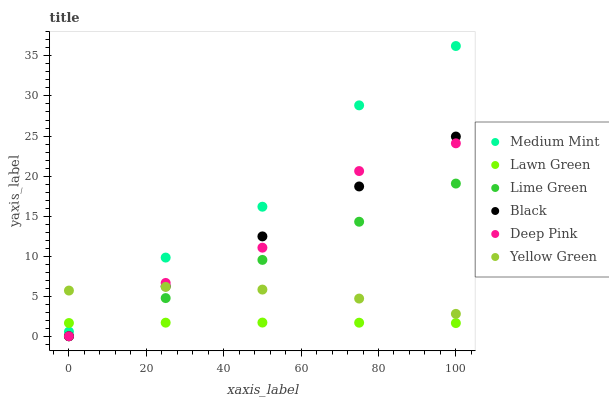Does Lawn Green have the minimum area under the curve?
Answer yes or no. Yes. Does Medium Mint have the maximum area under the curve?
Answer yes or no. Yes. Does Deep Pink have the minimum area under the curve?
Answer yes or no. No. Does Deep Pink have the maximum area under the curve?
Answer yes or no. No. Is Lime Green the smoothest?
Answer yes or no. Yes. Is Medium Mint the roughest?
Answer yes or no. Yes. Is Lawn Green the smoothest?
Answer yes or no. No. Is Lawn Green the roughest?
Answer yes or no. No. Does Deep Pink have the lowest value?
Answer yes or no. Yes. Does Lawn Green have the lowest value?
Answer yes or no. No. Does Medium Mint have the highest value?
Answer yes or no. Yes. Does Deep Pink have the highest value?
Answer yes or no. No. Is Black less than Medium Mint?
Answer yes or no. Yes. Is Medium Mint greater than Black?
Answer yes or no. Yes. Does Medium Mint intersect Yellow Green?
Answer yes or no. Yes. Is Medium Mint less than Yellow Green?
Answer yes or no. No. Is Medium Mint greater than Yellow Green?
Answer yes or no. No. Does Black intersect Medium Mint?
Answer yes or no. No. 